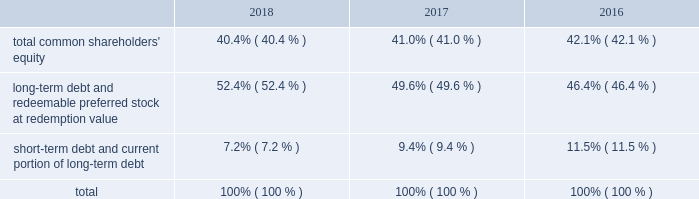Allows us to repurchase shares at times when we may otherwise be prevented from doing so under insider trading laws or because of self-imposed trading blackout periods .
Subject to applicable regulations , we may elect to amend or cancel this repurchase program or the share repurchase parameters at our discretion .
As of december 31 , 2018 , we have repurchased an aggregate of 4510000 shares of common stock under this program .
Credit facilities and short-term debt we have an unsecured revolving credit facility of $ 2.25 billion that expires in june 2023 .
In march 2018 , awcc and its lenders amended and restated the credit agreement with respect to awcc 2019s revolving credit facility to increase the maximum commitments under the facility from $ 1.75 billion to $ 2.25 billion , and to extend the expiration date of the facility from june 2020 to march 2023 .
All other terms , conditions and covenants with respect to the existing facility remained unchanged .
Subject to satisfying certain conditions , the credit agreement also permits awcc to increase the maximum commitment under the facility by up to an aggregate of $ 500 million , and to request extensions of its expiration date for up to two , one-year periods .
Interest rates on advances under the facility are based on a credit spread to the libor rate or base rate in accordance with moody investors service 2019s and standard & poor 2019s financial services 2019 then applicable credit rating on awcc 2019s senior unsecured , non-credit enhanced debt .
The facility is used principally to support awcc 2019s commercial paper program and to provide up to $ 150 million in letters of credit .
Indebtedness under the facility is considered 201cdebt 201d for purposes of a support agreement between the company and awcc , which serves as a functional equivalent of a guarantee by the company of awcc 2019s payment obligations under the credit facility .
Awcc also has an outstanding commercial paper program that is backed by the revolving credit facility , the maximum aggregate outstanding amount of which was increased in march 2018 , from $ 1.60 billion to $ 2.10 billion .
The table provides the aggregate credit facility commitments , letter of credit sub-limit under the revolving credit facility and commercial paper limit , as well as the available capacity for each as of december 31 , 2018 and 2017 : credit facility commitment available credit facility capacity letter of credit sublimit available letter of credit capacity commercial paper limit available commercial capacity ( in millions ) december 31 , 2018 .
$ 2262 $ 2177 $ 150 $ 69 $ 2100 $ 1146 december 31 , 2017 .
1762 1673 150 66 1600 695 the weighted average interest rate on awcc short-term borrowings for the years ended december 31 , 2018 and 2017 was approximately 2.28% ( 2.28 % ) and 1.24% ( 1.24 % ) , respectively .
Capital structure the table provides the percentage of our capitalization represented by the components of our capital structure as of december 31: .

By how much did the short-term debt and current portion of long-term debt portion of the capital structure decrease from 2016 to 2018? 
Computations: (7.2% - 11.5%)
Answer: -0.043. 